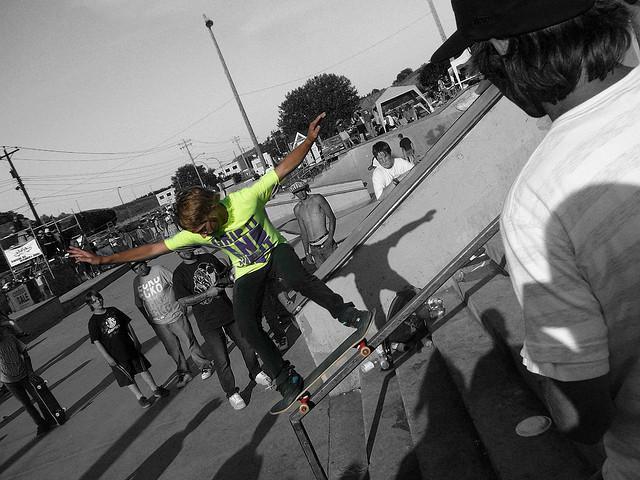How many on a skateboard?
Give a very brief answer. 1. How many people can be seen?
Give a very brief answer. 7. 